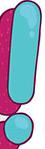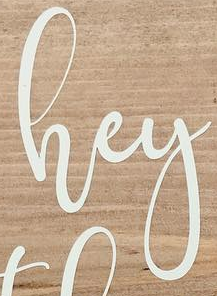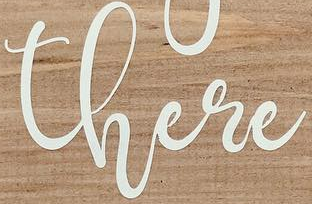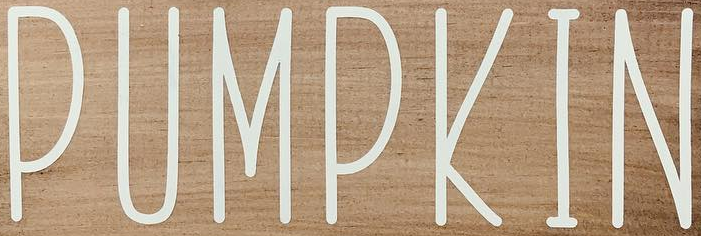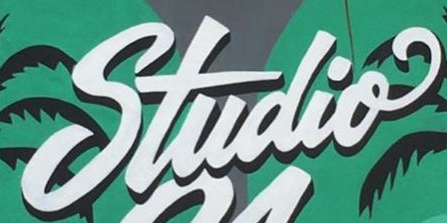What text is displayed in these images sequentially, separated by a semicolon? !; hey; there; PUMPKIN; Studio 